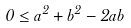<formula> <loc_0><loc_0><loc_500><loc_500>0 \leq a ^ { 2 } + b ^ { 2 } - 2 a b</formula> 